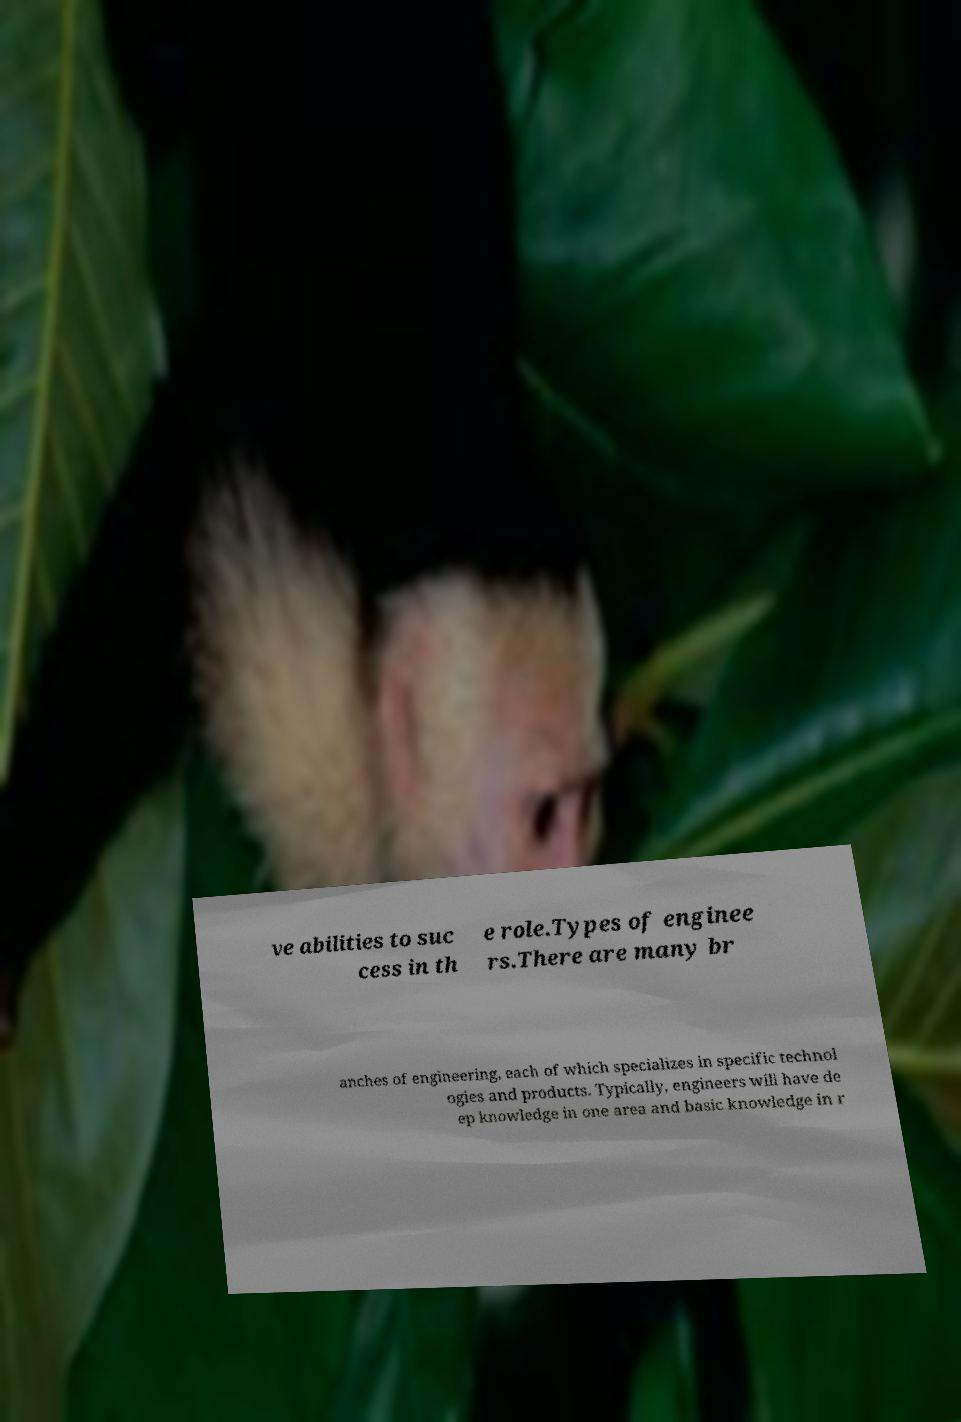Please read and relay the text visible in this image. What does it say? ve abilities to suc cess in th e role.Types of enginee rs.There are many br anches of engineering, each of which specializes in specific technol ogies and products. Typically, engineers will have de ep knowledge in one area and basic knowledge in r 